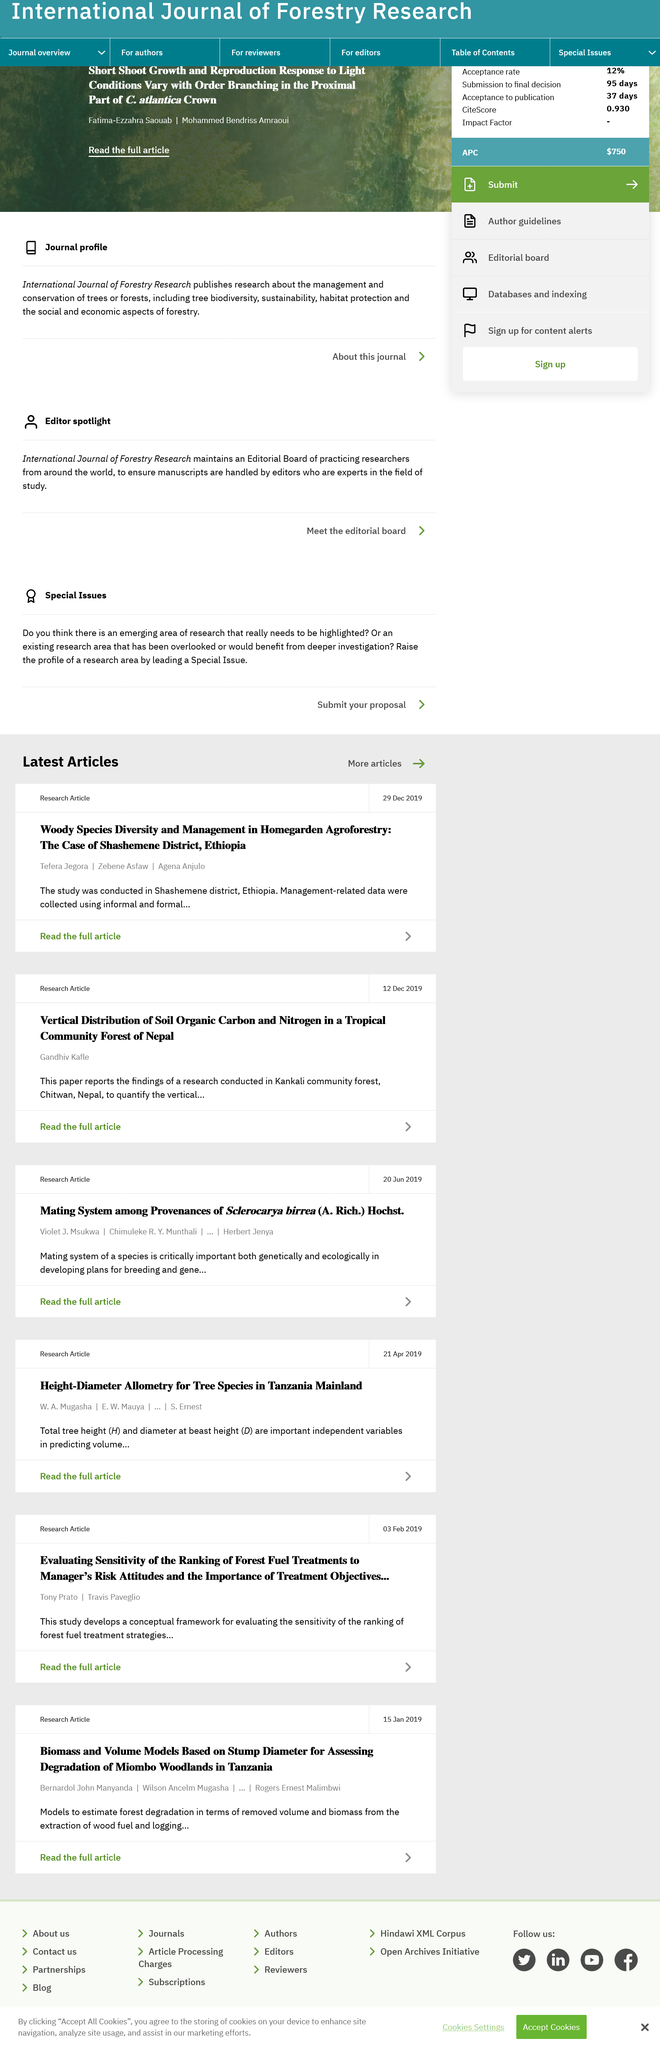Mention a couple of crucial points in this snapshot. Kankali Community Forest located in Chitwan, Nepal, is a recognized community-managed forest area that is well-known for its rich biodiversity and cultural heritage. The research article titled "Vertical Distribution of Soil Organic Carbon and Nitrogen in a Tropical Community Forest of Nepal" studies the Kankali Community Forest. The Woody Species Diversity and Management in Homegarden Agroforestry study was conducted in Shashemene District, Ethiopia. 